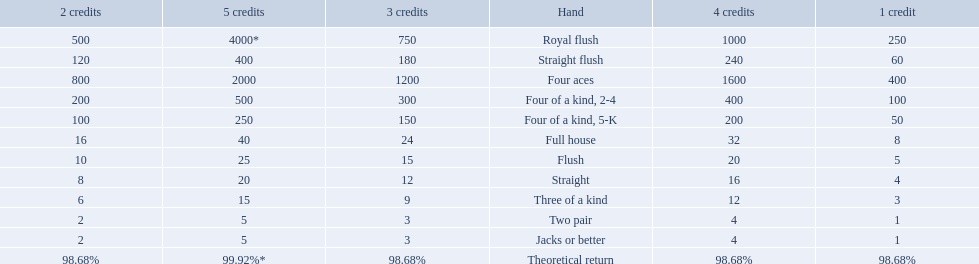What are each of the hands? Royal flush, Straight flush, Four aces, Four of a kind, 2-4, Four of a kind, 5-K, Full house, Flush, Straight, Three of a kind, Two pair, Jacks or better, Theoretical return. Which hand ranks higher between straights and flushes? Flush. 